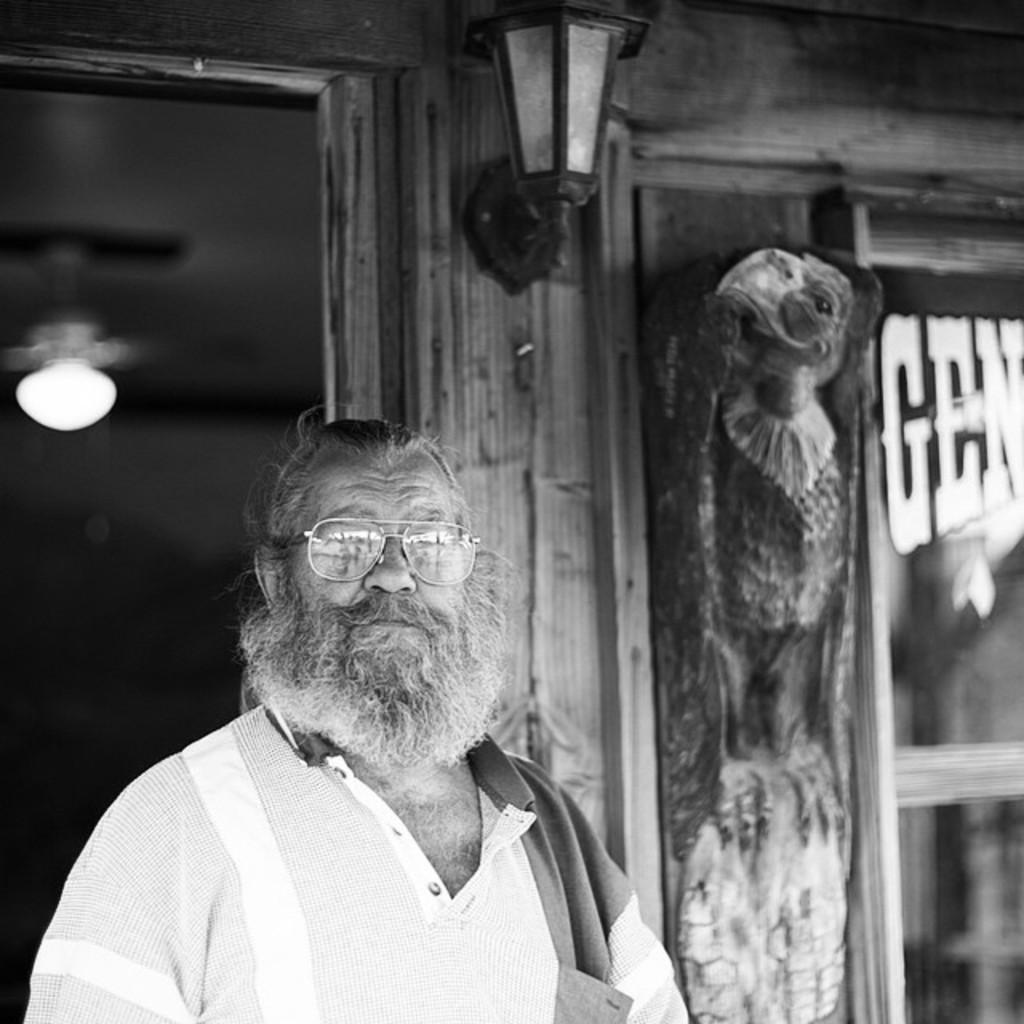Who is the main subject in the image? There is an old man with a long beard in the image. What is the old man doing in the image? The old man is standing in the front and looking at the camera. What can be seen in the background of the image? There is a wooden panel wall in the background. What type of lighting is present on the wooden panel wall? There is a black wall light on the wooden panel wall. What type of music can be heard playing in the background of the image? There is no music present in the image; it is a still photograph of an old man with a long beard. 